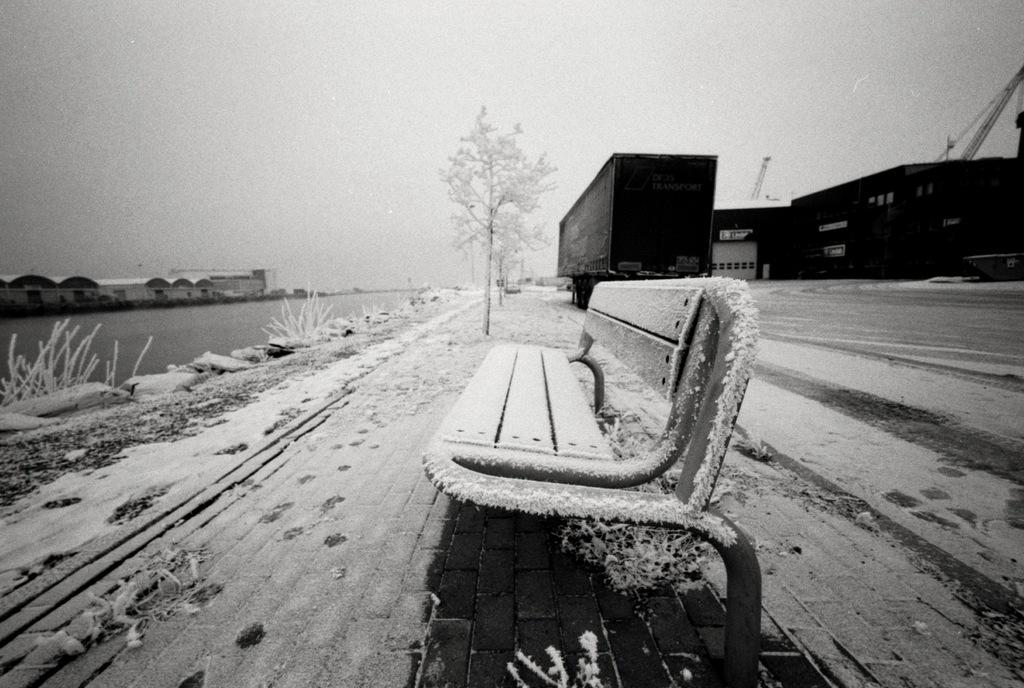What type of seating is present in the image? There is a bench in the image. What type of vegetation can be seen in the image? There are trees in the image. What objects are present for holding or storing items? There are containers in the image. What natural element is visible in the image? Water is visible in the image. What is the condition of the houses in the image? The houses are covered with snow in the image. What is visible in the background of the image? The sky is visible in the background of the image. How many eggs are visible on the bench in the image? There are no eggs present on the bench or in the image. What type of plant is growing on the trees in the image? The provided facts do not mention any specific plants growing on the trees; only the presence of trees is mentioned. 